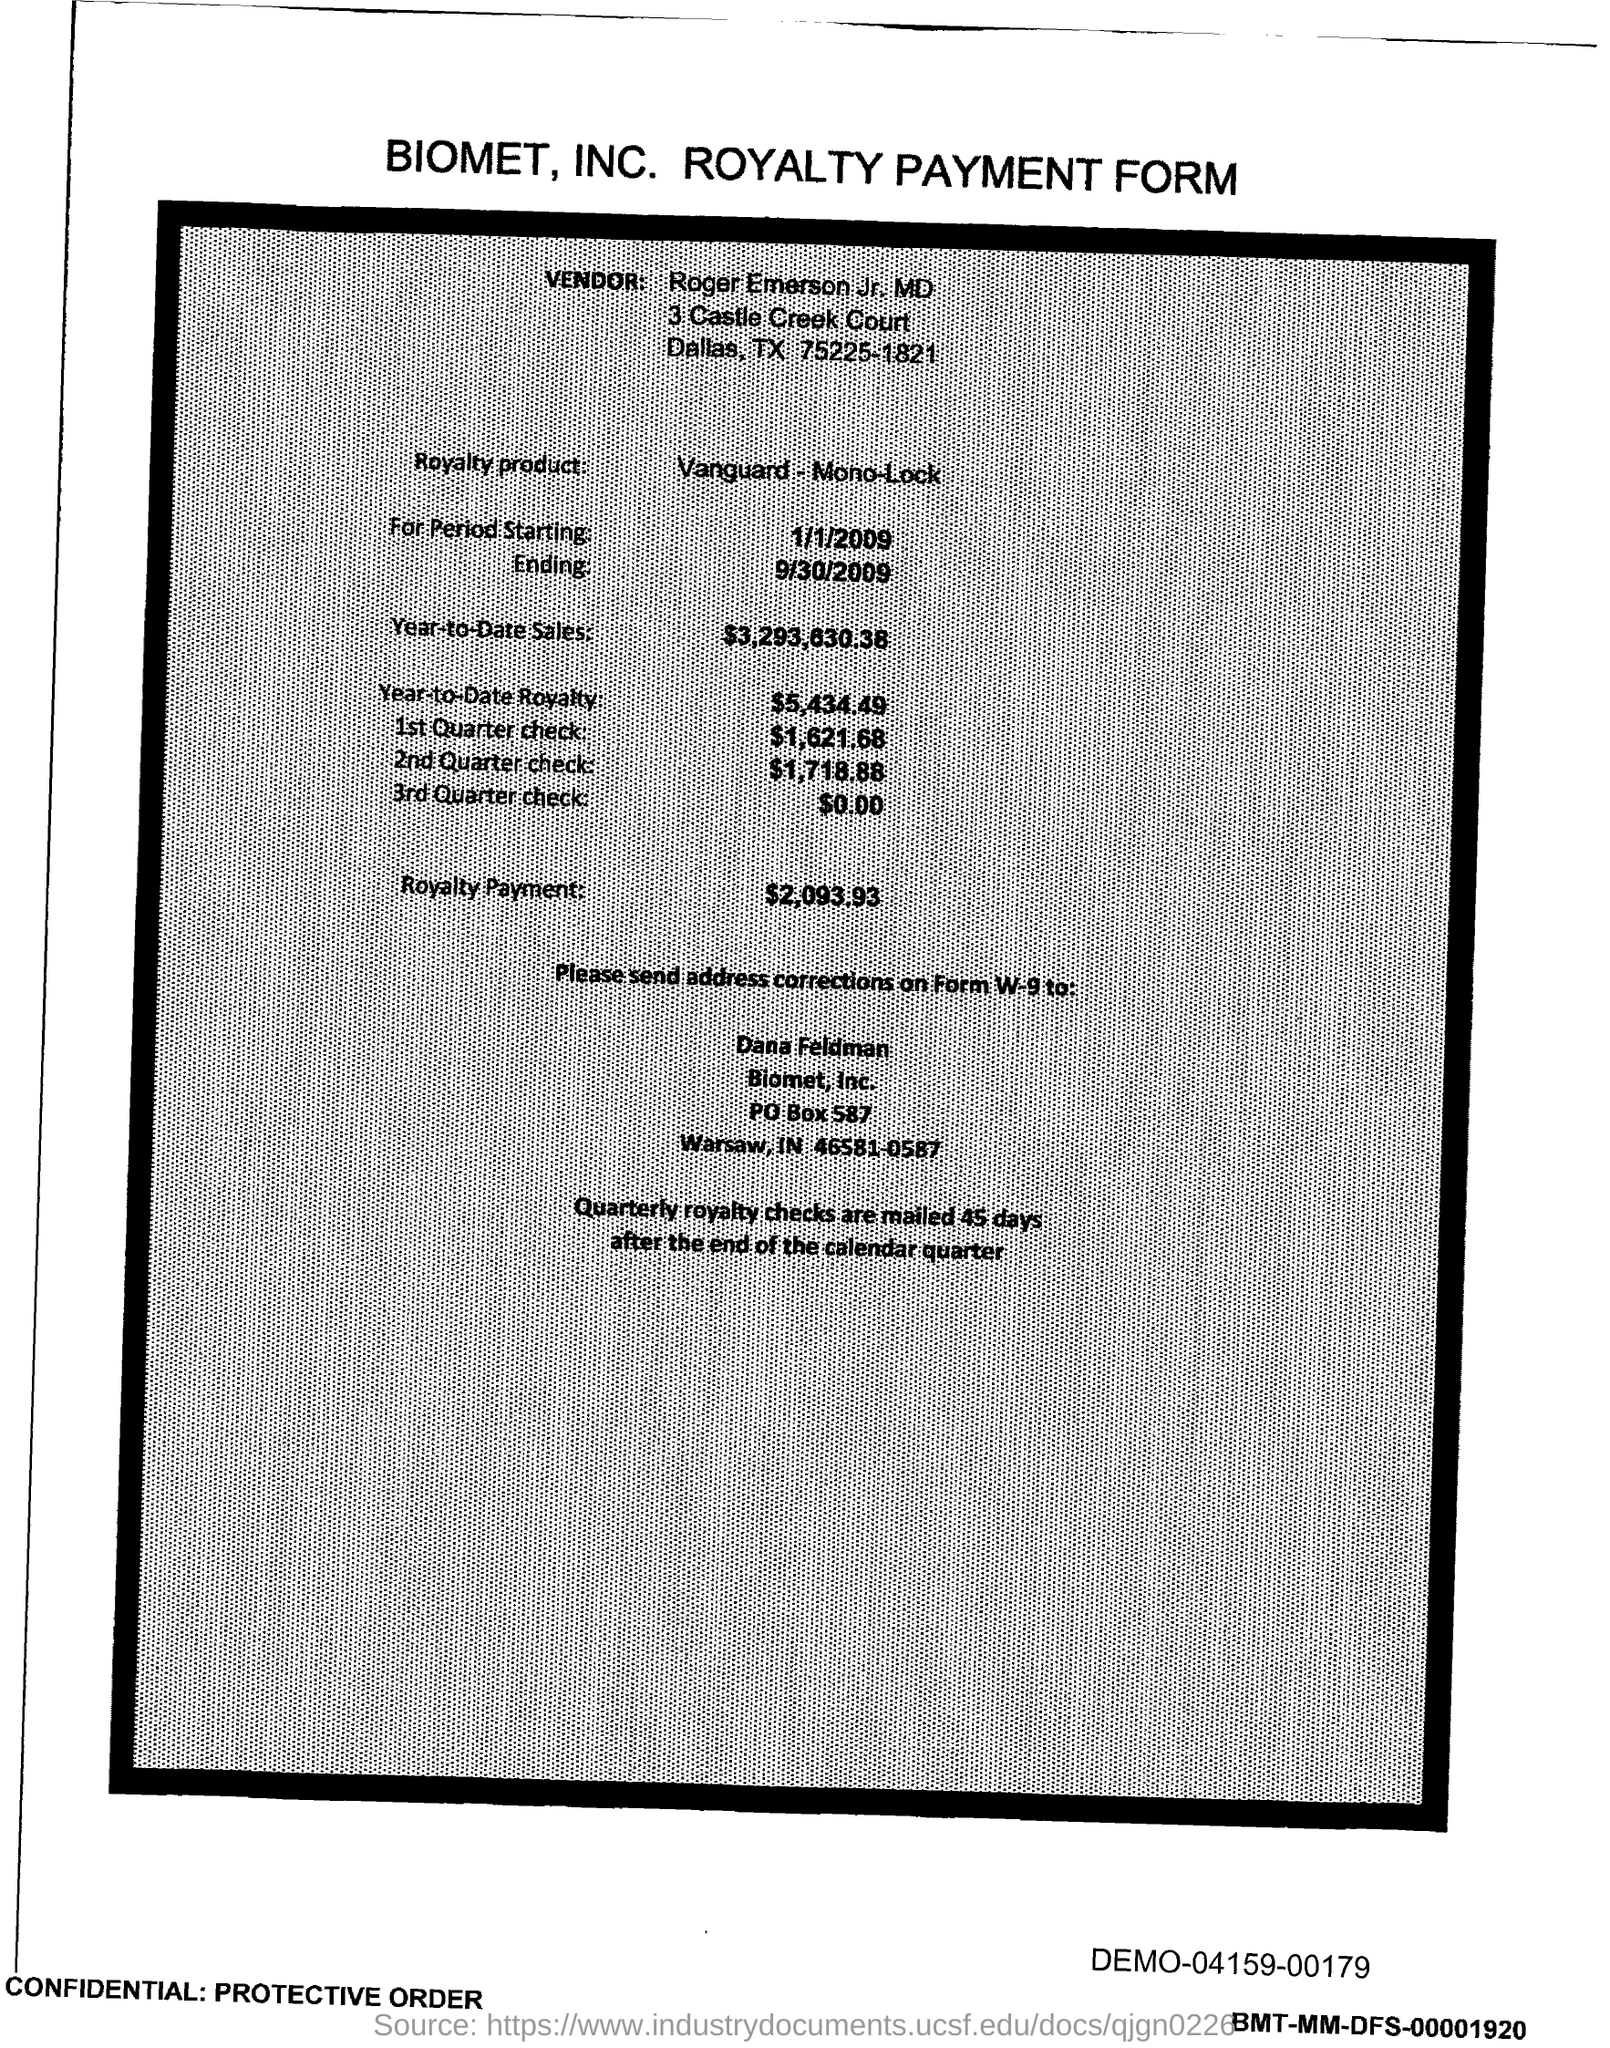Mention a couple of crucial points in this snapshot. The PO Box number mentioned in the document is 587. 